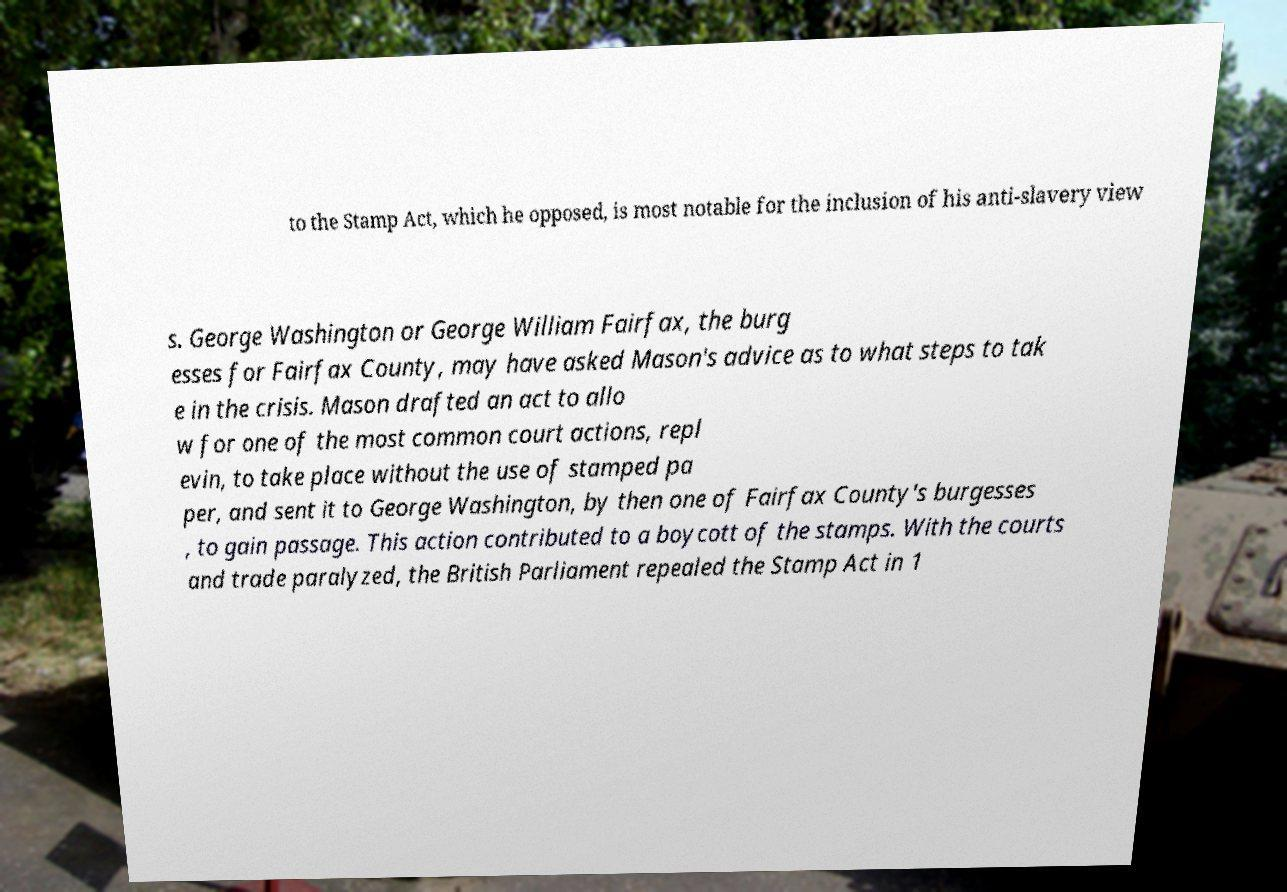For documentation purposes, I need the text within this image transcribed. Could you provide that? to the Stamp Act, which he opposed, is most notable for the inclusion of his anti-slavery view s. George Washington or George William Fairfax, the burg esses for Fairfax County, may have asked Mason's advice as to what steps to tak e in the crisis. Mason drafted an act to allo w for one of the most common court actions, repl evin, to take place without the use of stamped pa per, and sent it to George Washington, by then one of Fairfax County's burgesses , to gain passage. This action contributed to a boycott of the stamps. With the courts and trade paralyzed, the British Parliament repealed the Stamp Act in 1 